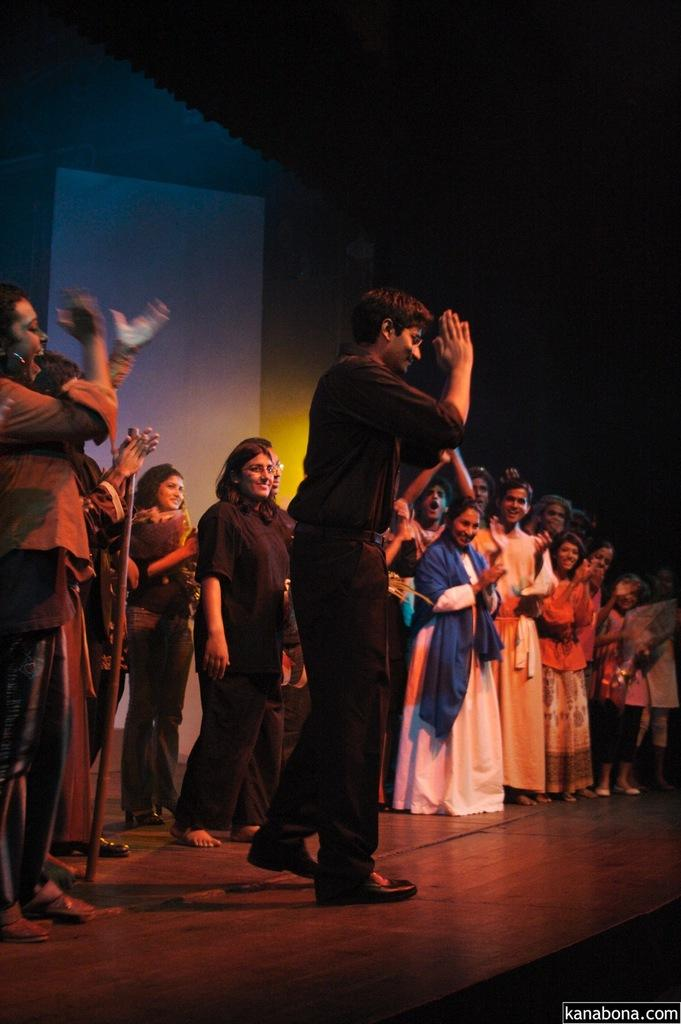How many people are in the image? There is a group of persons in the image. What are the people in the image doing? The persons are standing and smiling. What can be seen in the background of the image? There is a curtain in the background of the image. What is the color of the curtain? The curtain is white in color. What type of liquid is being poured from the person's skin in the image? There is no liquid being poured from anyone's skin in the image. What fictional character is depicted in the image? The image does not depict any fictional characters; it features a group of persons standing and smiling. 